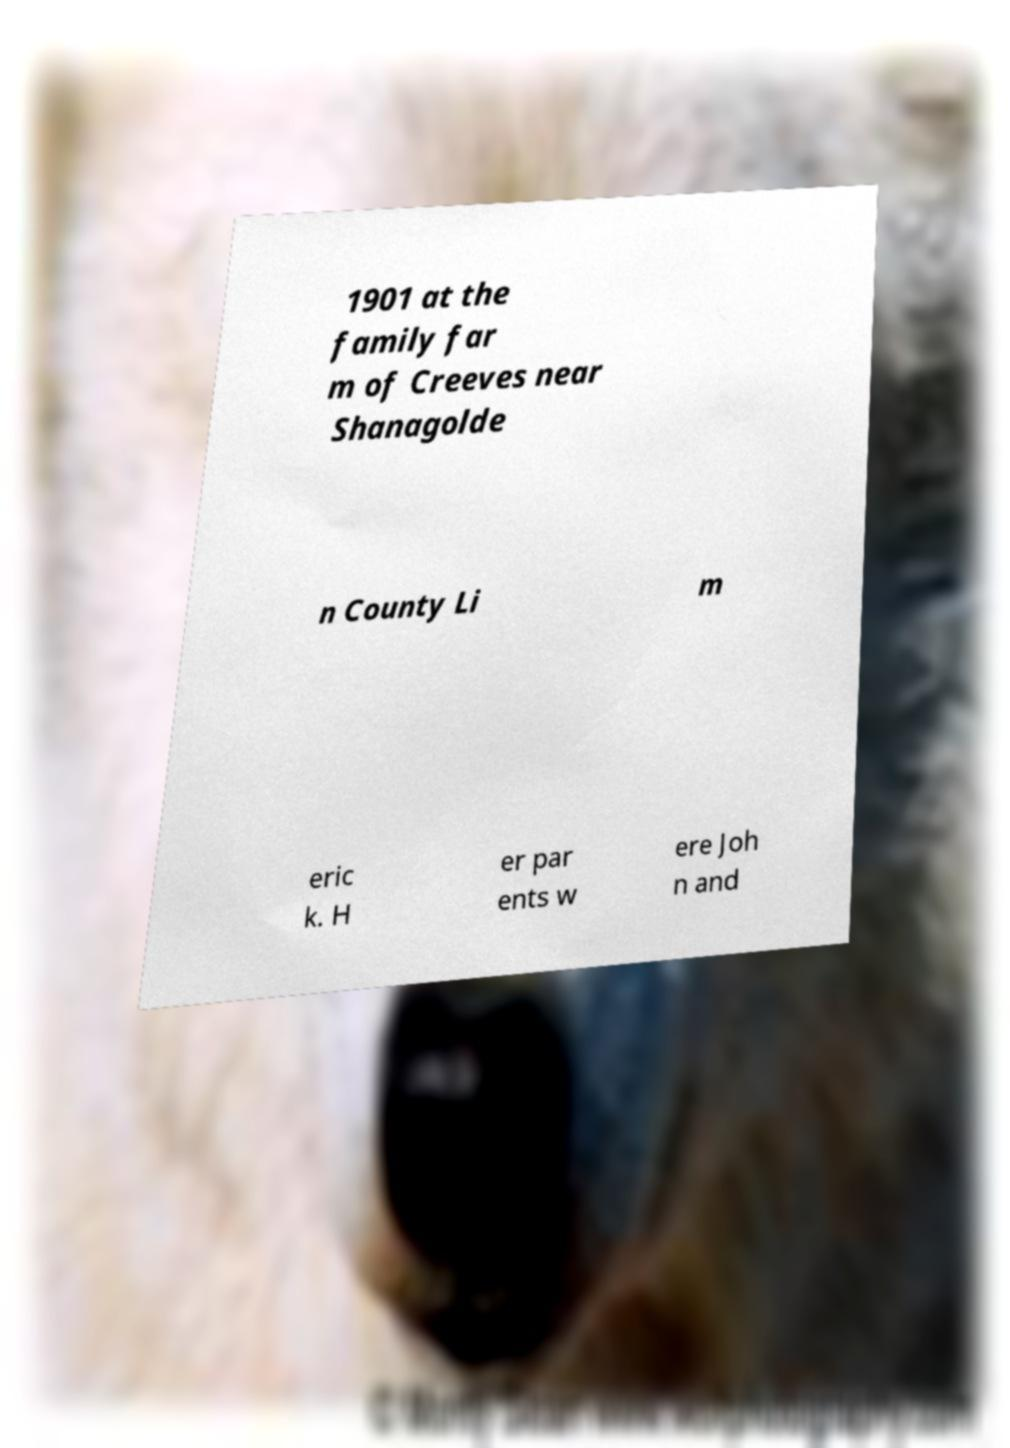Please identify and transcribe the text found in this image. 1901 at the family far m of Creeves near Shanagolde n County Li m eric k. H er par ents w ere Joh n and 